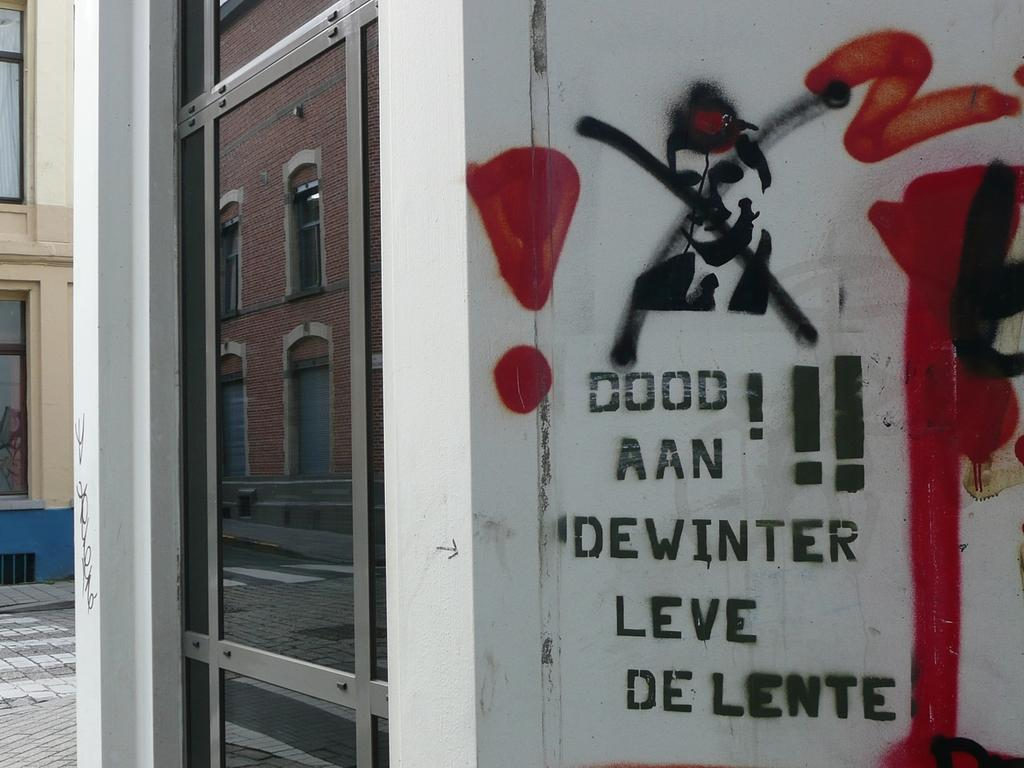What is hanging on the wall in the image? There is a poster on the wall in the image. What feature of a building can be seen in the image? The walls of a building are visible in the image. Is there any entrance or exit visible in the image? Yes, there is a door in the image. Can you tell me how many dinosaurs are visible in the image? There are no dinosaurs present in the image. What event is taking place in the image? There is no event depicted in the image; it shows a poster on the wall, a door, and the walls of a building. 